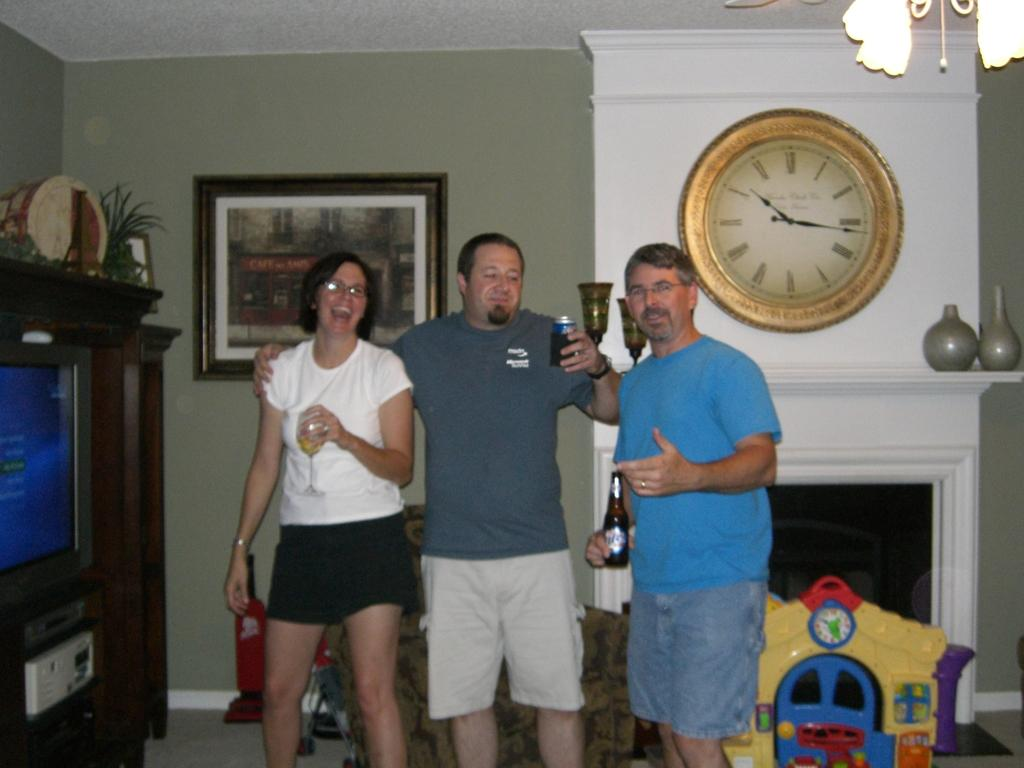<image>
Present a compact description of the photo's key features. Three people in a living room with a clock time around ten 